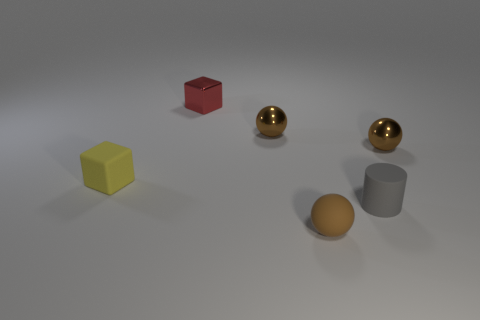Add 2 tiny brown matte cylinders. How many objects exist? 8 Subtract all small metal balls. How many balls are left? 1 Subtract all cylinders. How many objects are left? 5 Subtract all red blocks. How many blocks are left? 1 Subtract 0 cyan cylinders. How many objects are left? 6 Subtract 1 cubes. How many cubes are left? 1 Subtract all cyan cylinders. Subtract all green spheres. How many cylinders are left? 1 Subtract all purple cubes. How many cyan cylinders are left? 0 Subtract all small yellow matte cubes. Subtract all tiny matte cylinders. How many objects are left? 4 Add 5 tiny blocks. How many tiny blocks are left? 7 